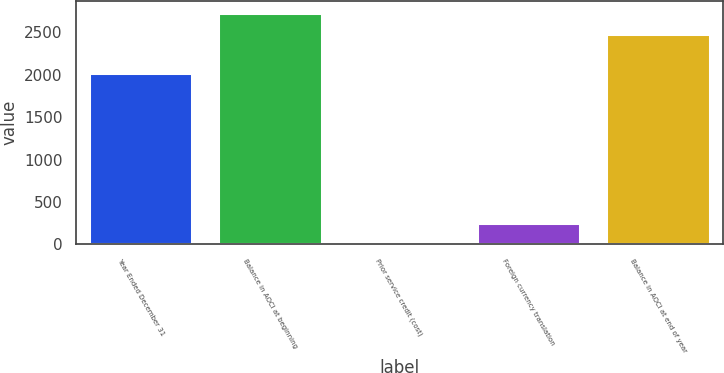<chart> <loc_0><loc_0><loc_500><loc_500><bar_chart><fcel>Year Ended December 31<fcel>Balance in AOCI at beginning<fcel>Prior service credit (cost)<fcel>Foreign currency translation<fcel>Balance in AOCI at end of year<nl><fcel>2018<fcel>2731.2<fcel>1<fcel>250.2<fcel>2482<nl></chart> 